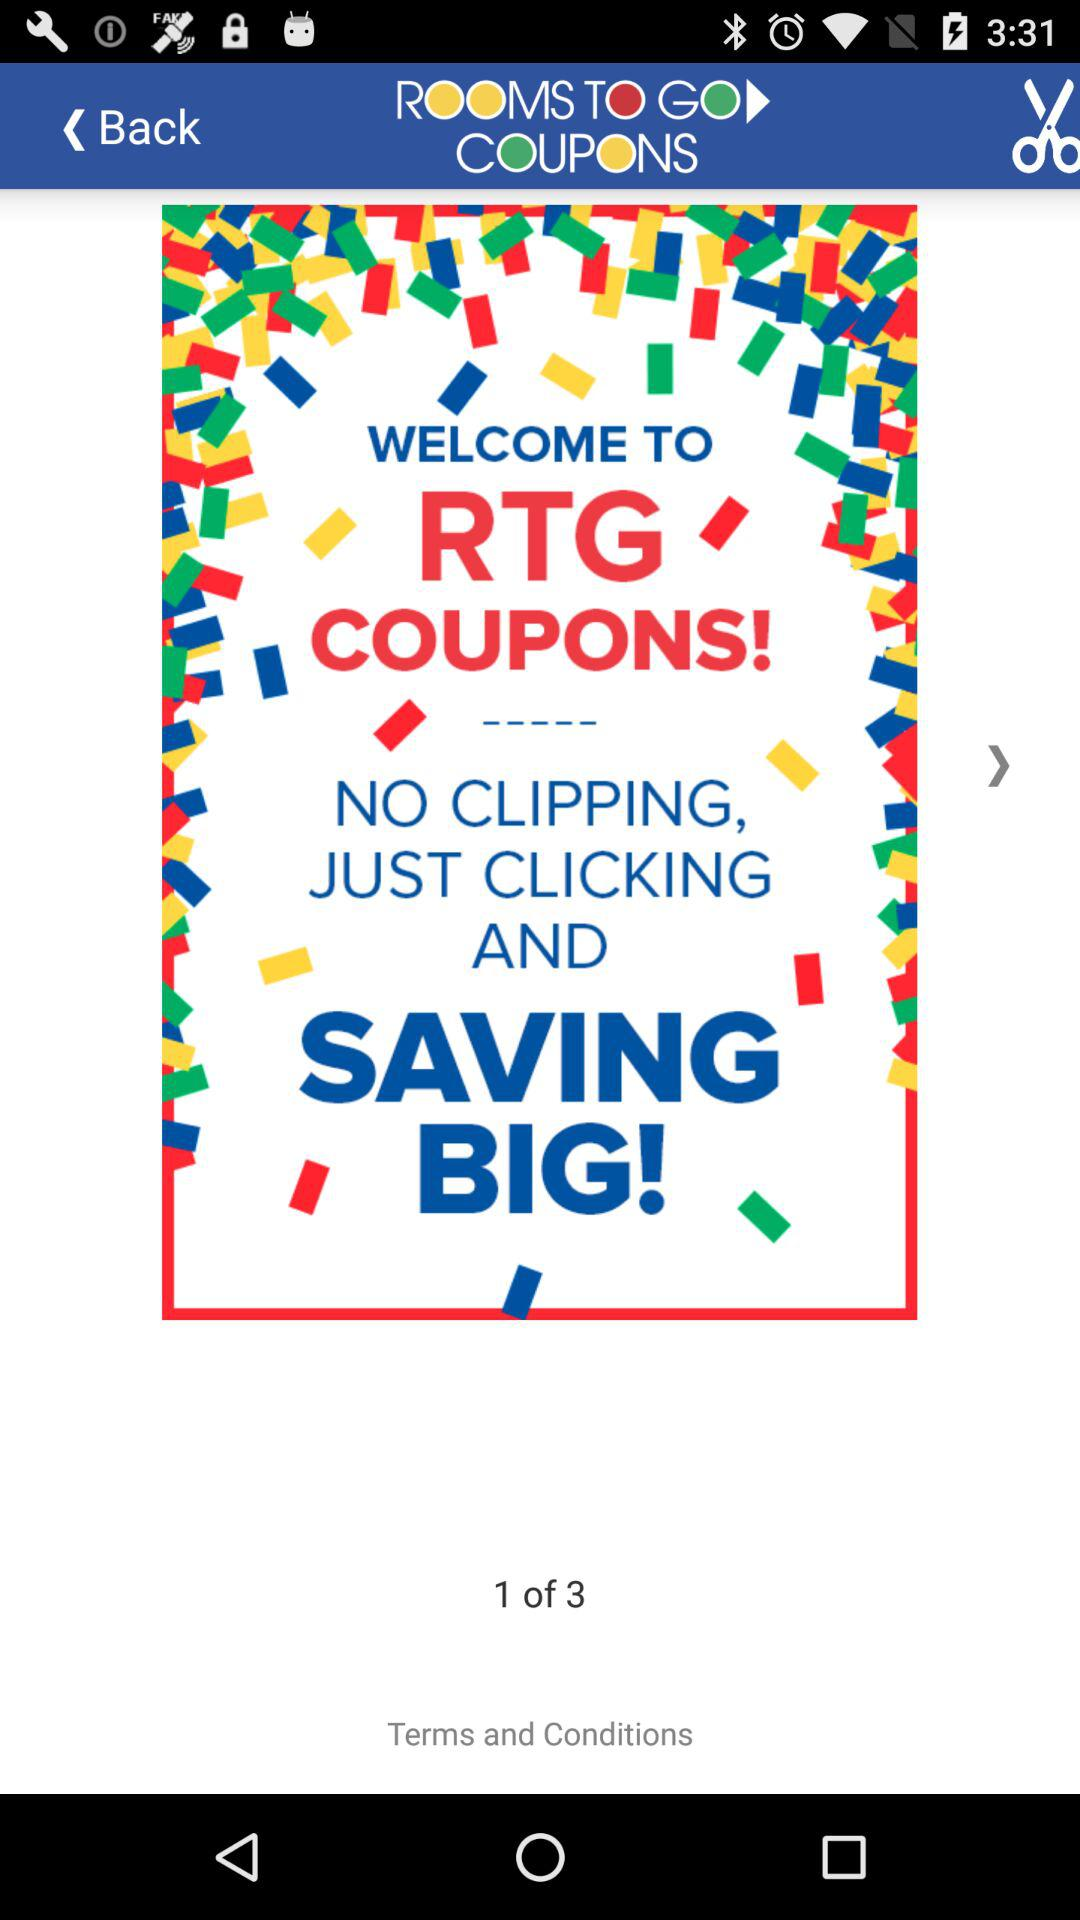Which is the current room shown? The current room shown is 1. 